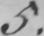Transcribe the text shown in this historical manuscript line. 5 . 